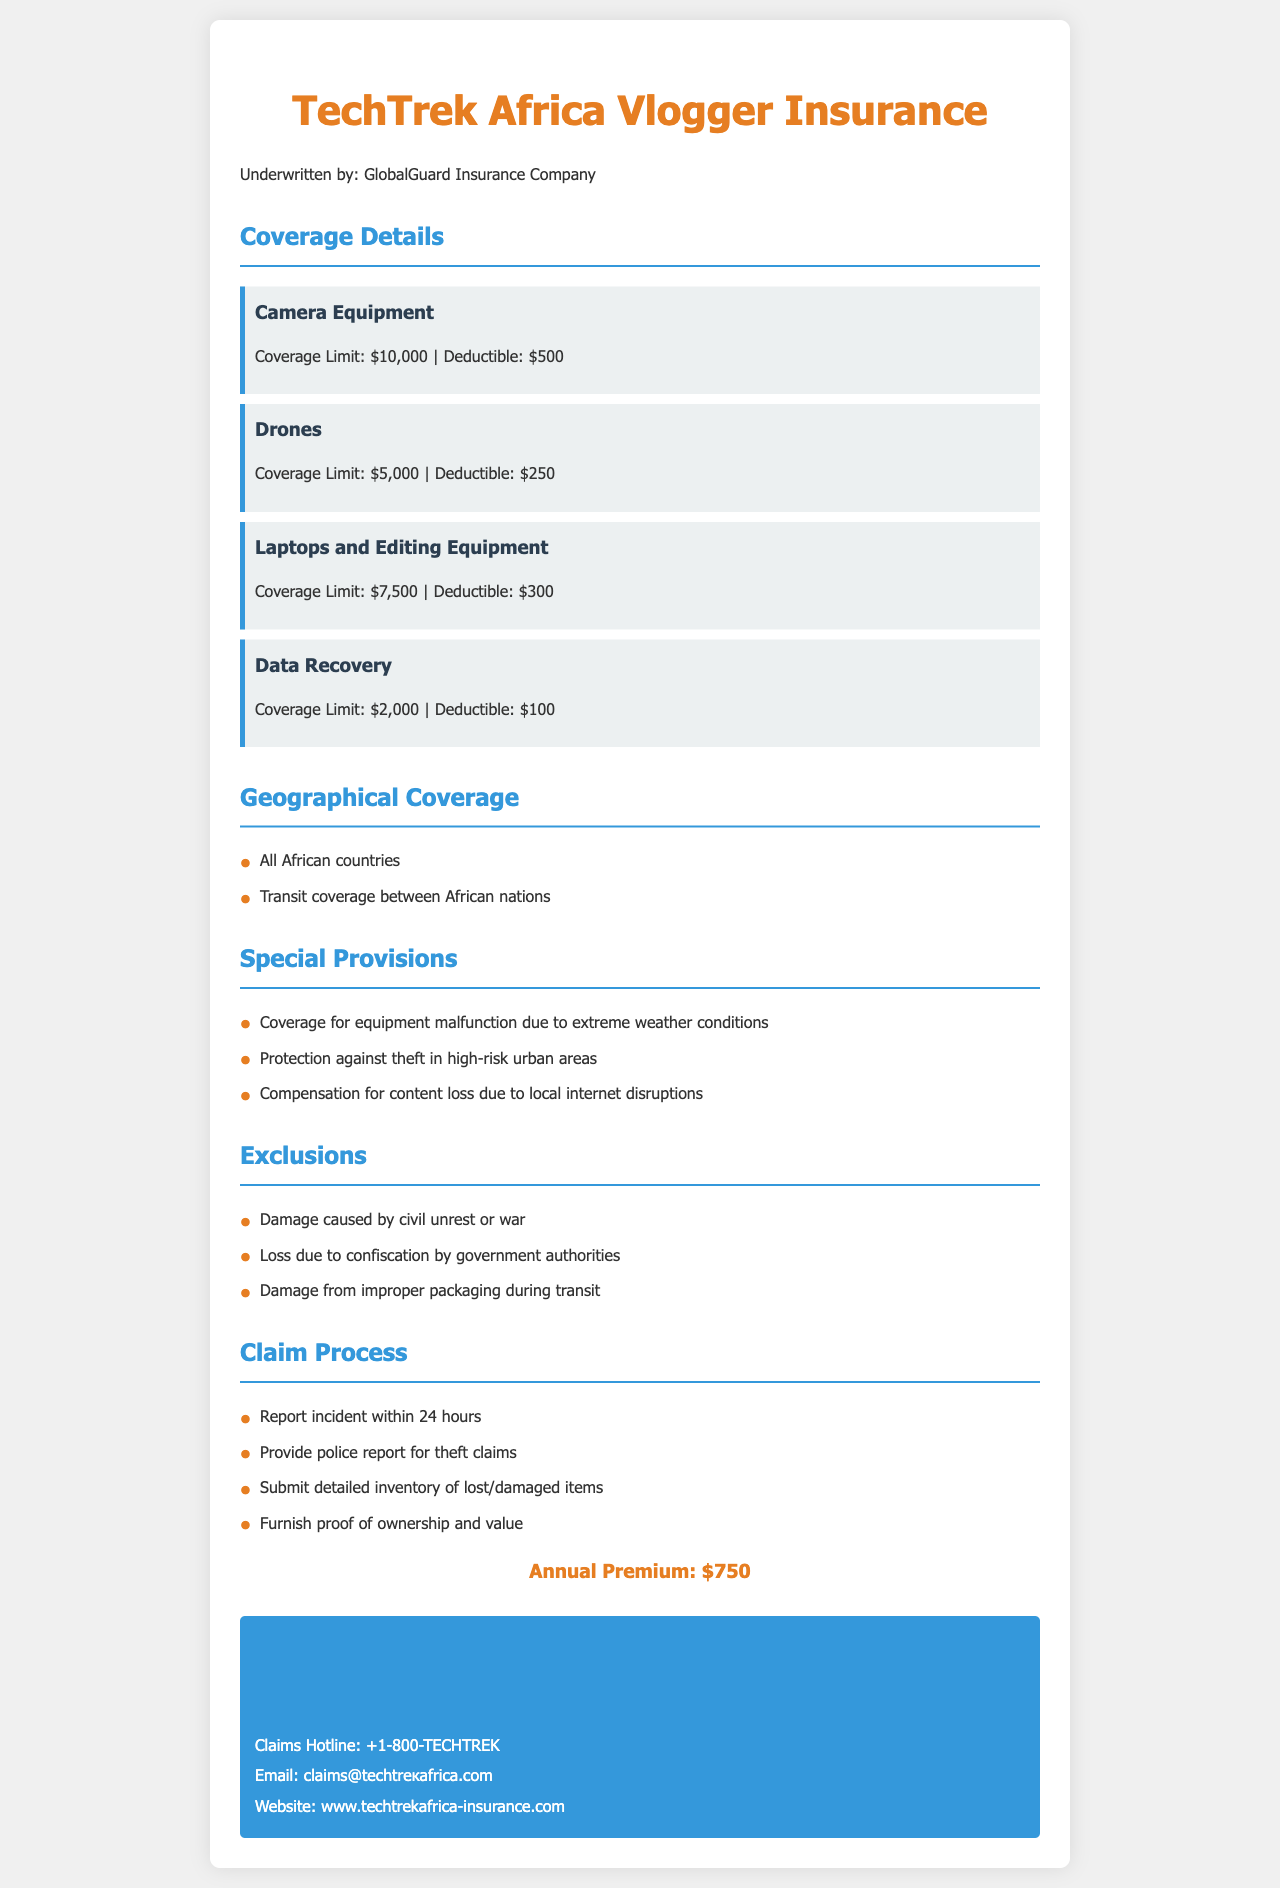what is the annual premium? The annual premium is stated clearly in the document, which is $750.
Answer: $750 what is the coverage limit for drones? The coverage limit for drones is specified in the coverage details section of the document as $5,000.
Answer: $5,000 which company underwrites the insurance? The document mentions that the insurance is underwritten by GlobalGuard Insurance Company.
Answer: GlobalGuard Insurance Company what is the deductible for camera equipment? The document specifies the deductible for camera equipment to be $500.
Answer: $500 which countries are covered by the insurance policy? The geographical coverage section lists that all African countries are covered.
Answer: All African countries what is excluded from the insurance coverage? The document outlines specific exclusions, including damage caused by civil unrest or war.
Answer: Damage caused by civil unrest or war how long do you have to report an incident? The claim process section states that an incident must be reported within 24 hours.
Answer: 24 hours what is the coverage limit for data recovery? The document indicates the coverage limit for data recovery is $2,000.
Answer: $2,000 what types of theft are covered? Special provisions state protection against theft in high-risk urban areas is included.
Answer: Theft in high-risk urban areas 